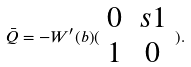Convert formula to latex. <formula><loc_0><loc_0><loc_500><loc_500>\bar { Q } = - W ^ { \prime } ( b ) ( \begin{array} { c c } 0 & s 1 \\ 1 & 0 \end{array} ) .</formula> 